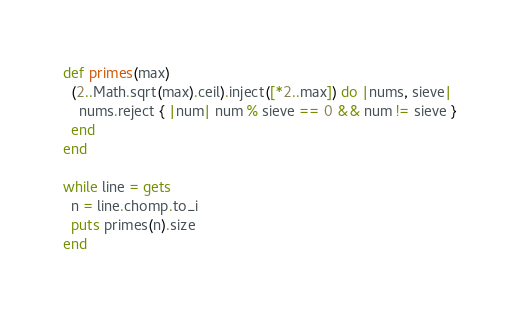<code> <loc_0><loc_0><loc_500><loc_500><_Ruby_>def primes(max)
  (2..Math.sqrt(max).ceil).inject([*2..max]) do |nums, sieve|
    nums.reject { |num| num % sieve == 0 && num != sieve }
  end
end

while line = gets
  n = line.chomp.to_i
  puts primes(n).size
end</code> 